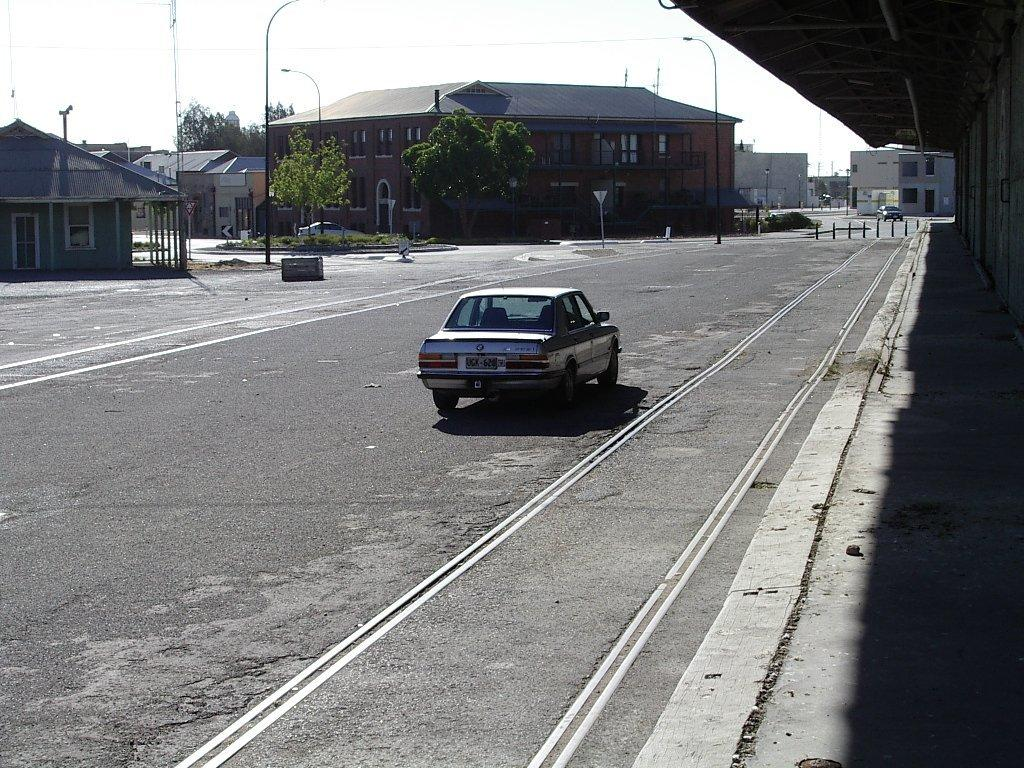What is the main subject of the image? The main subject of the image is a car. What is the car doing in the image? The car is moving on the road in the image. What can be seen in the middle of the image besides the car? There are trees in the middle of the image. What type of structures are visible in the image? There are houses in the image. How many dimes can be seen on the car's windshield in the image? There are no dimes visible on the car's windshield in the image. What type of punishment is being given to the car in the image? There is no punishment being given to the car in the image; it is simply moving on the road. 